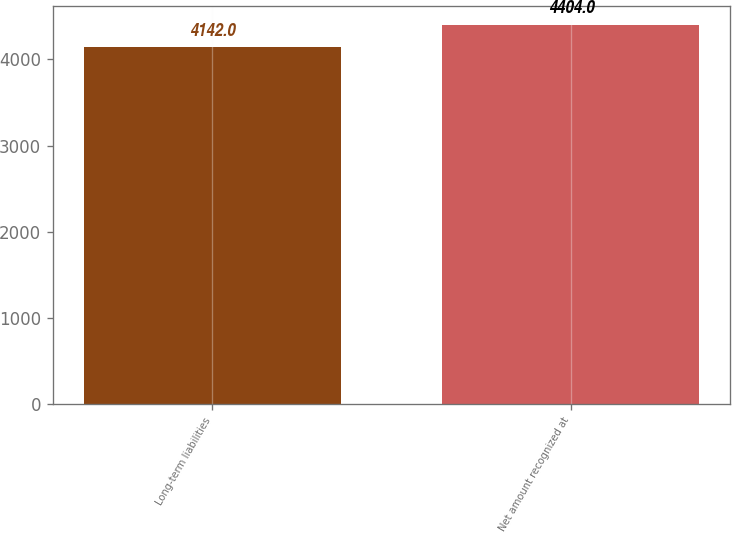Convert chart. <chart><loc_0><loc_0><loc_500><loc_500><bar_chart><fcel>Long-term liabilities<fcel>Net amount recognized at<nl><fcel>4142<fcel>4404<nl></chart> 